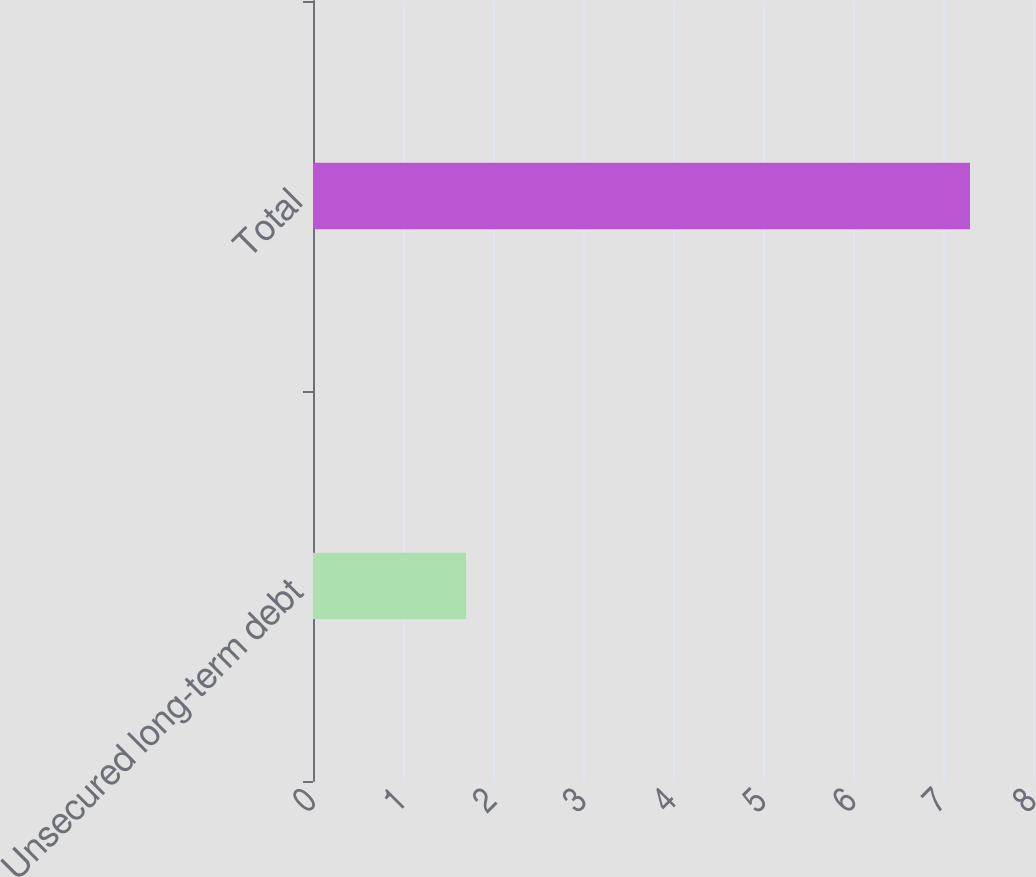Convert chart. <chart><loc_0><loc_0><loc_500><loc_500><bar_chart><fcel>Unsecured long-term debt<fcel>Total<nl><fcel>1.7<fcel>7.3<nl></chart> 